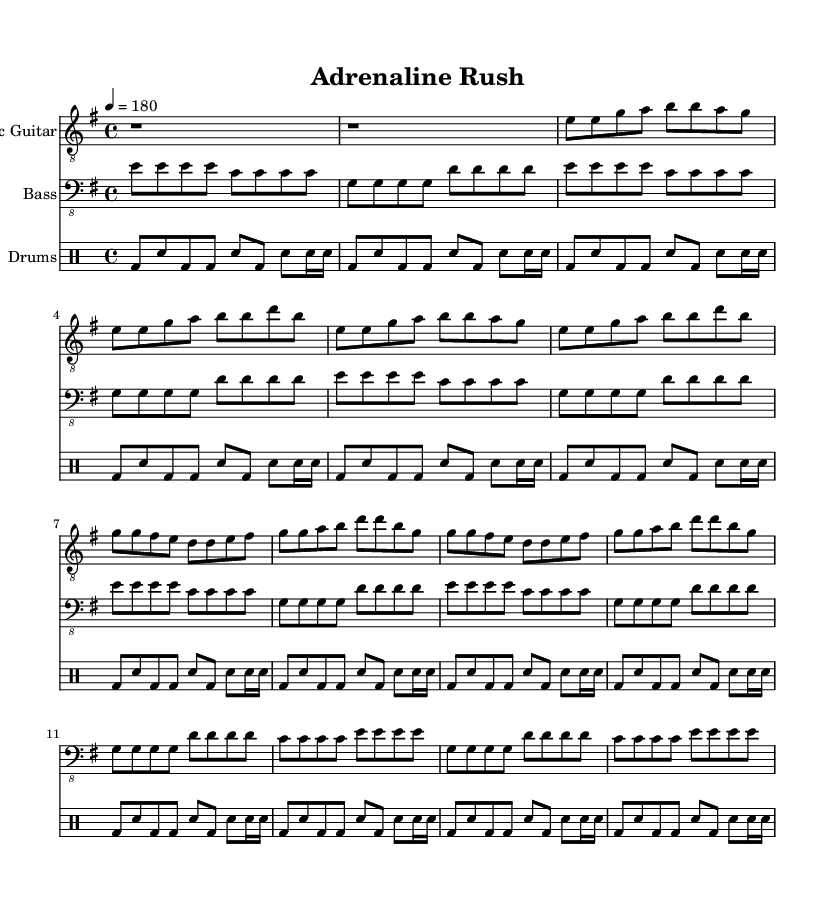What is the key signature of this music? The key signature is E minor, which has one sharp (F#).
Answer: E minor What is the time signature of this music? The time signature is indicated by the notation at the beginning, showing 4 beats per measure.
Answer: 4/4 What is the tempo of this music? The tempo marking states "4 = 180," indicating that there are 180 beats per minute.
Answer: 180 How many measures are in the verse section? The verse consists of 4 measures, as indicated by the repeated musical phrases within this section.
Answer: 4 Which instrument plays the lowest notes throughout the piece? The bass guitar consistently plays the lowest pitches among the three parts presented.
Answer: Bass How many times is the chorus repeated? The chorus section is indicated to be repeated two times throughout the score, as shown in the repeated section notations.
Answer: 2 What rhythmic element is prominent in the drums part? The drum score predominantly features the bass drum playing on the downbeats, creating a strong driving rhythm typical in punk rock.
Answer: Bass drum 